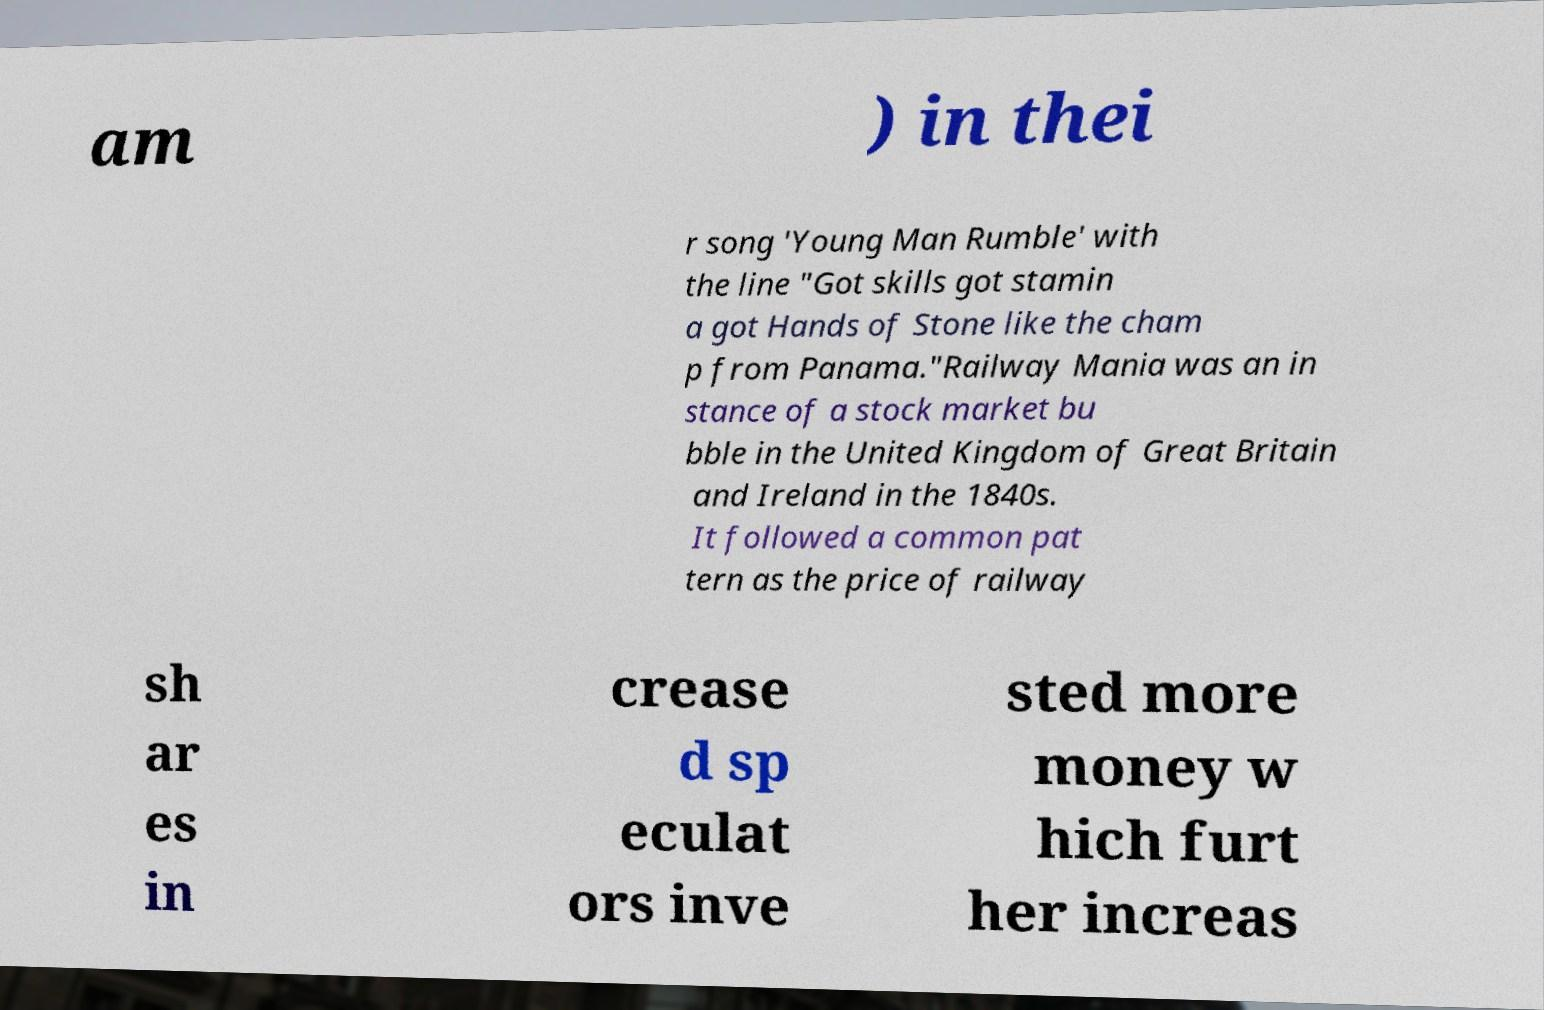Can you accurately transcribe the text from the provided image for me? am ) in thei r song 'Young Man Rumble' with the line "Got skills got stamin a got Hands of Stone like the cham p from Panama."Railway Mania was an in stance of a stock market bu bble in the United Kingdom of Great Britain and Ireland in the 1840s. It followed a common pat tern as the price of railway sh ar es in crease d sp eculat ors inve sted more money w hich furt her increas 